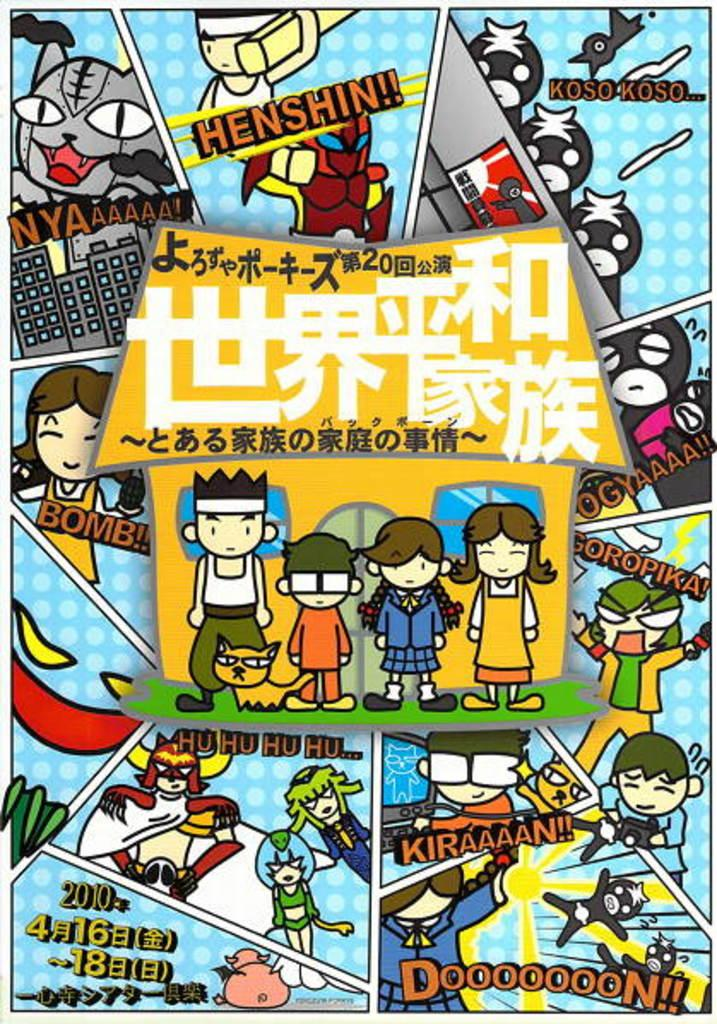Provide a one-sentence caption for the provided image. A colorful page from a comic about a family. 